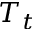<formula> <loc_0><loc_0><loc_500><loc_500>T _ { t }</formula> 